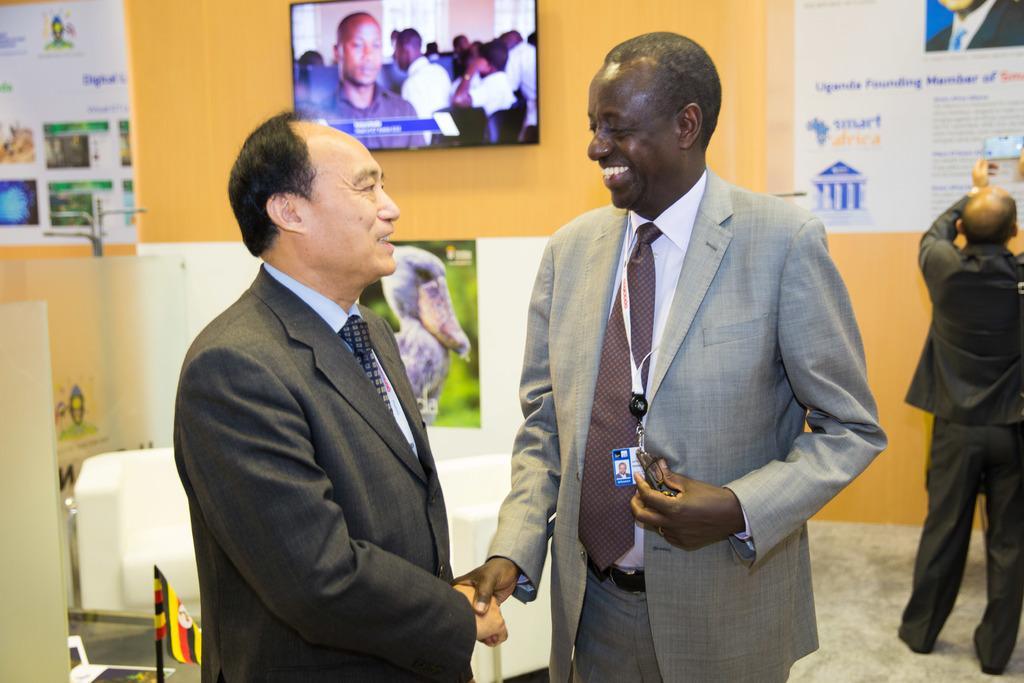How would you summarize this image in a sentence or two? In the front of the image two men are giving each-other a handshake and looking at each-other. In the background there is a flag, hoarding, posters, person, television and things. Posters and television is on the wall.   